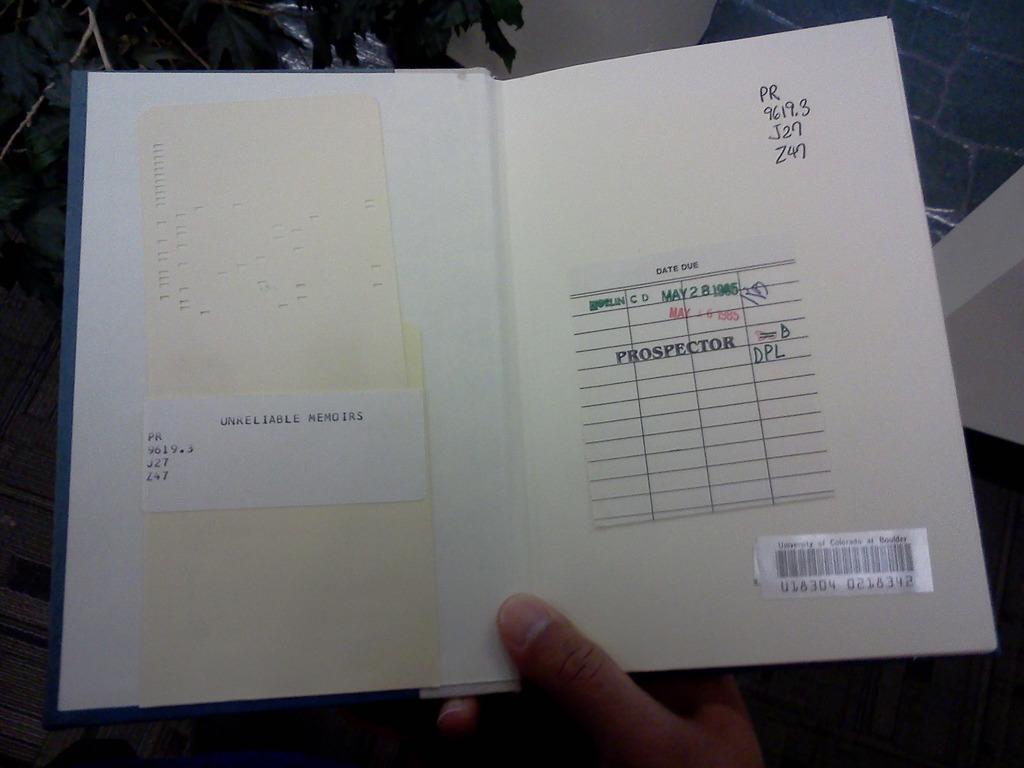What is the name of this book?
Keep it short and to the point. Unreliable memoirs. 